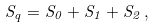<formula> <loc_0><loc_0><loc_500><loc_500>S _ { q } = S _ { 0 } + S _ { 1 } + S _ { 2 } \, ,</formula> 